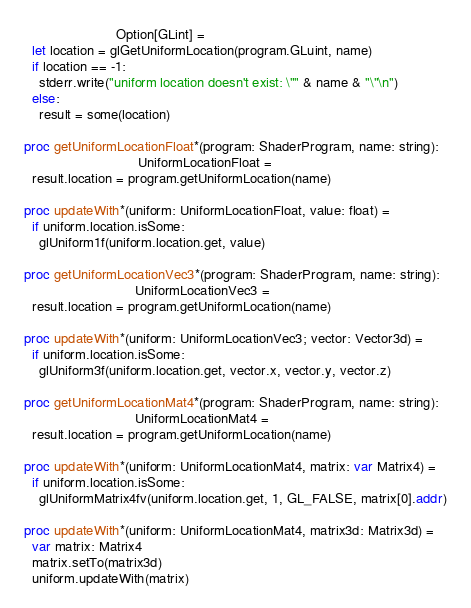Convert code to text. <code><loc_0><loc_0><loc_500><loc_500><_Nim_>                        Option[GLint] =
  let location = glGetUniformLocation(program.GLuint, name)
  if location == -1:
    stderr.write("uniform location doesn't exist: \"" & name & "\"\n")
  else:
    result = some(location)

proc getUniformLocationFloat*(program: ShaderProgram, name: string):
                              UniformLocationFloat =
  result.location = program.getUniformLocation(name)

proc updateWith*(uniform: UniformLocationFloat, value: float) =
  if uniform.location.isSome:
    glUniform1f(uniform.location.get, value)

proc getUniformLocationVec3*(program: ShaderProgram, name: string):
                             UniformLocationVec3 =
  result.location = program.getUniformLocation(name)

proc updateWith*(uniform: UniformLocationVec3; vector: Vector3d) =
  if uniform.location.isSome:
    glUniform3f(uniform.location.get, vector.x, vector.y, vector.z)

proc getUniformLocationMat4*(program: ShaderProgram, name: string):
                             UniformLocationMat4 =
  result.location = program.getUniformLocation(name)

proc updateWith*(uniform: UniformLocationMat4, matrix: var Matrix4) =
  if uniform.location.isSome:
    glUniformMatrix4fv(uniform.location.get, 1, GL_FALSE, matrix[0].addr)

proc updateWith*(uniform: UniformLocationMat4, matrix3d: Matrix3d) =
  var matrix: Matrix4
  matrix.setTo(matrix3d)
  uniform.updateWith(matrix)
</code> 